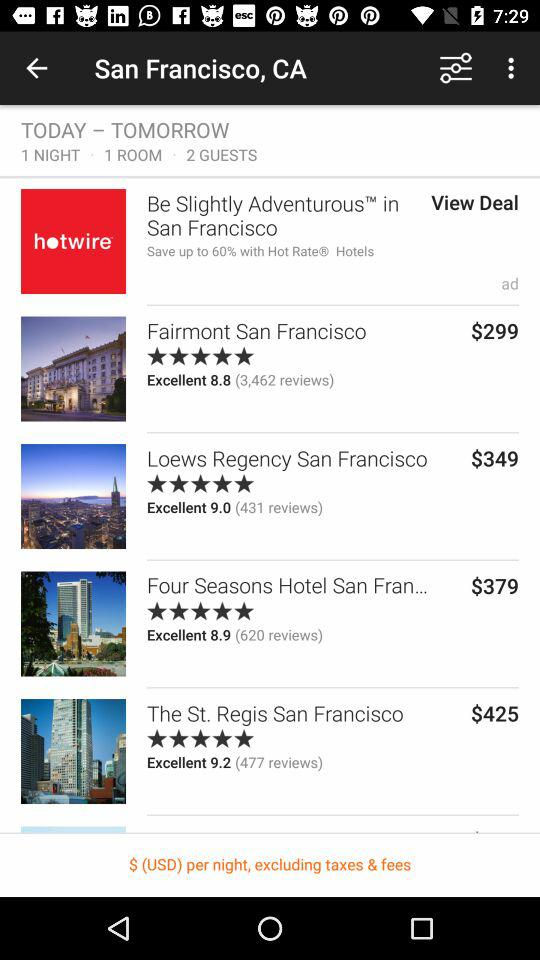What is the booking cost of "Loews Regency San Francisco"? The booking cost is $349. 